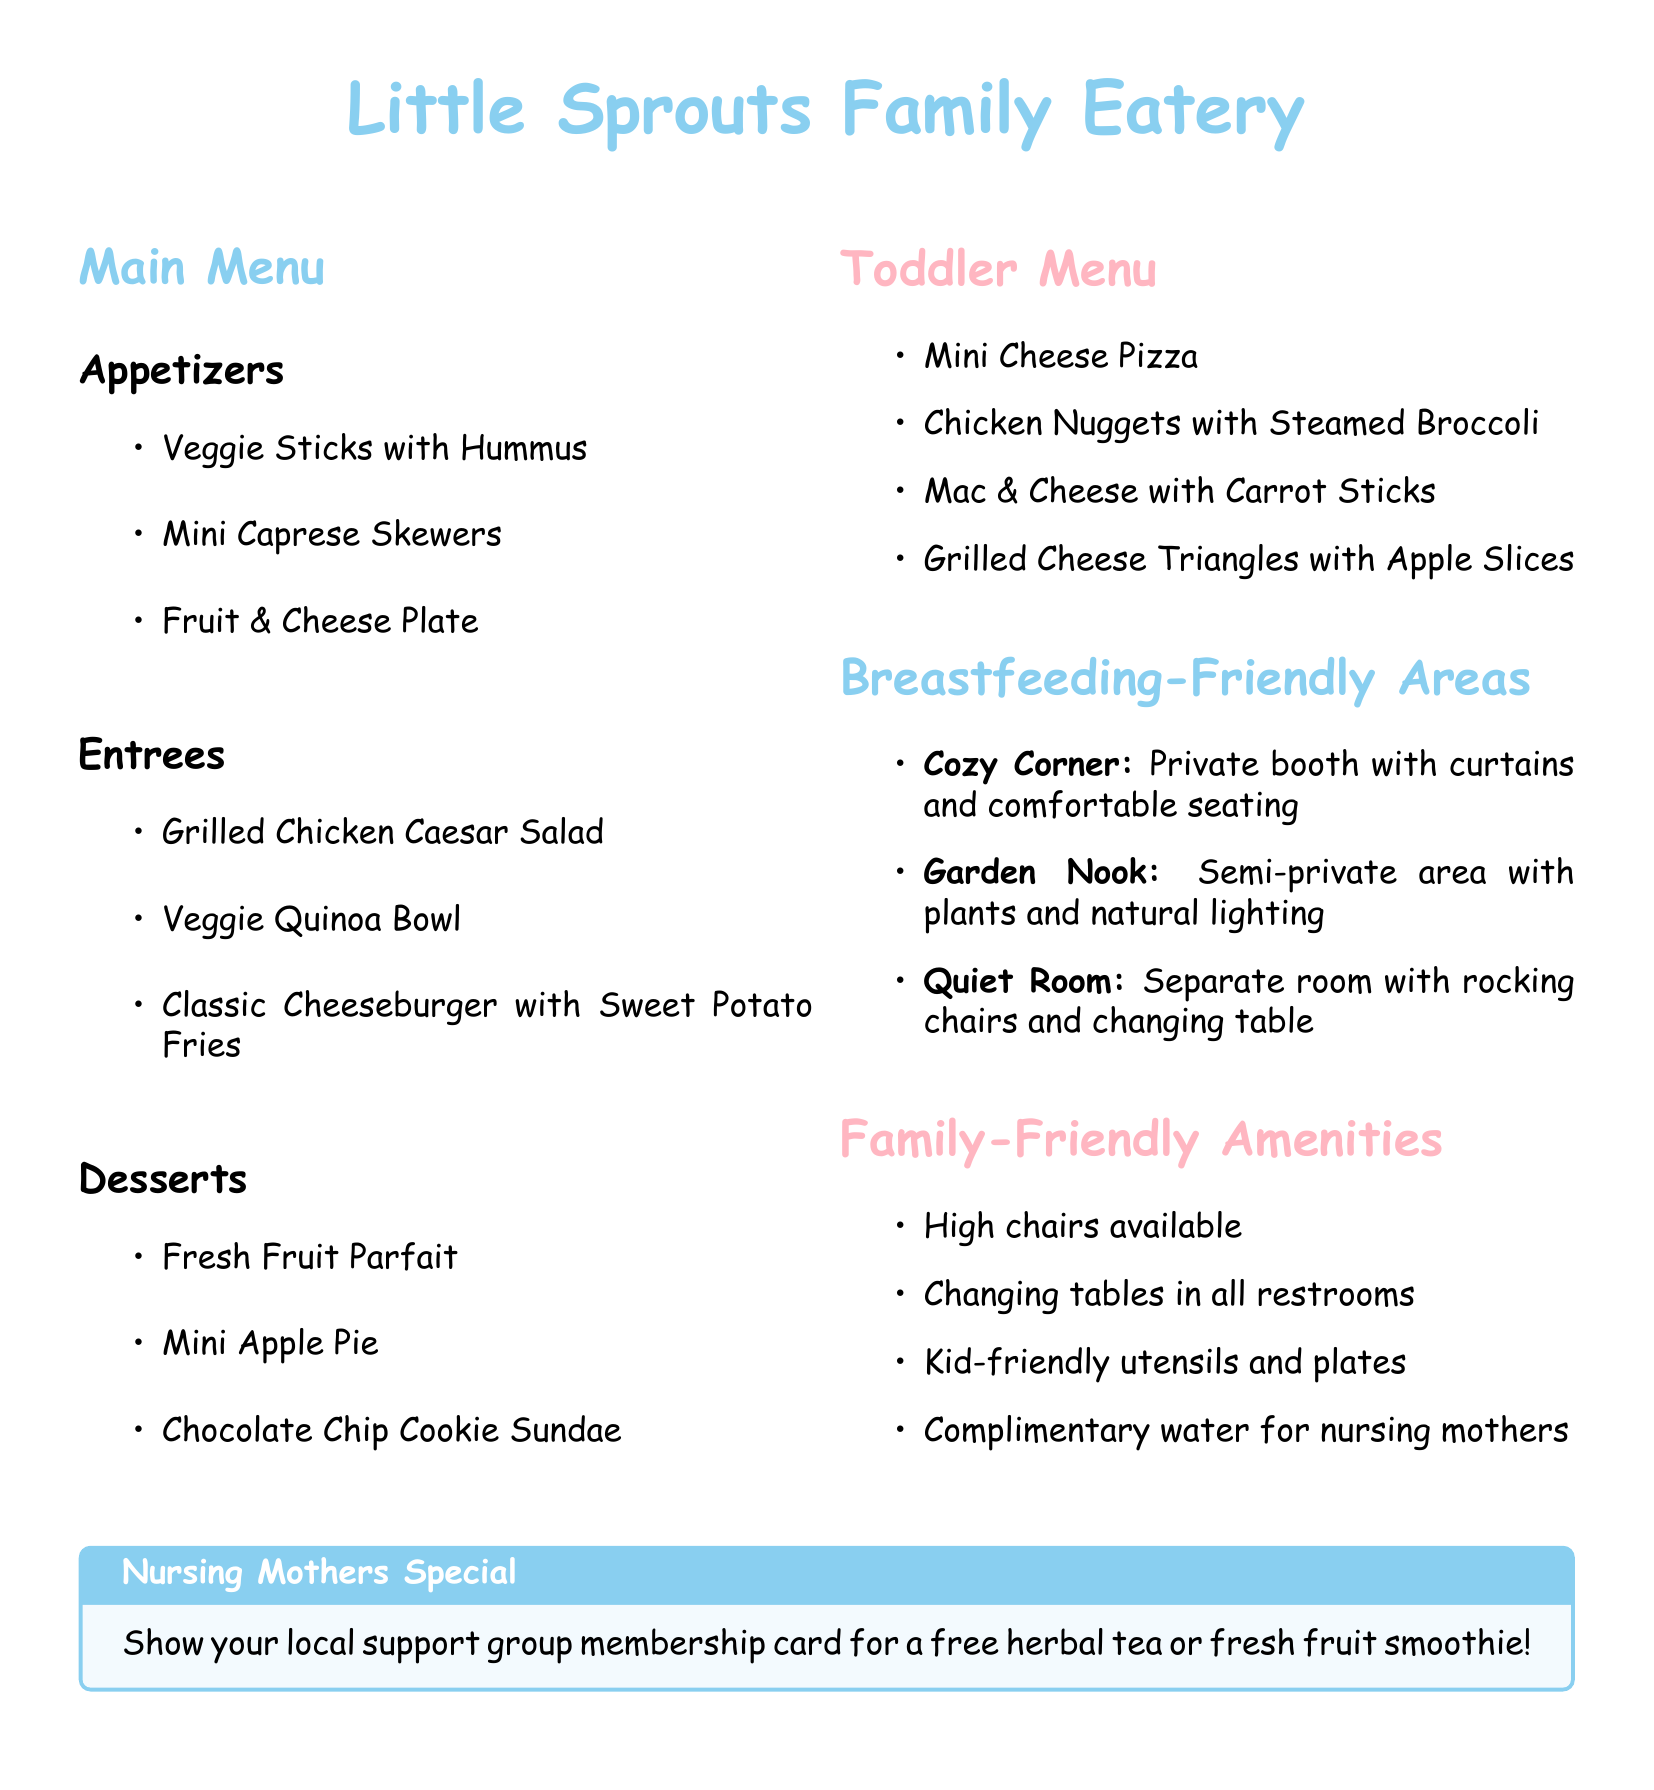What is the name of the restaurant? The name of the restaurant is stated at the top of the document.
Answer: Little Sprouts Family Eatery How many items are on the toddler menu? The toddler menu lists the number of items provided under that section.
Answer: Four What type of salad is available on the main menu? The main menu includes a specific type of salad described in the entrees section.
Answer: Grilled Chicken Caesar Salad Which breastfeeding-friendly area has a changing table? The document specifies which area is designed for a specific function related to breastfeeding.
Answer: Quiet Room What amenities are offered for families? The family-friendly amenities listed can be found in a specific section of the document.
Answer: High chairs available What special offer do nursing mothers get? The document contains a special offer for nursing mothers that is highlighted in a box.
Answer: Free herbal tea or fresh fruit smoothie What is one item served on the toddler menu? The toddler menu has a number of items, and one can be directly referenced from that section.
Answer: Mini Cheese Pizza Which area is a private booth for nursing mothers? The breastfeeding-friendly areas describe different types of seating areas for nursing.
Answer: Cozy Corner 